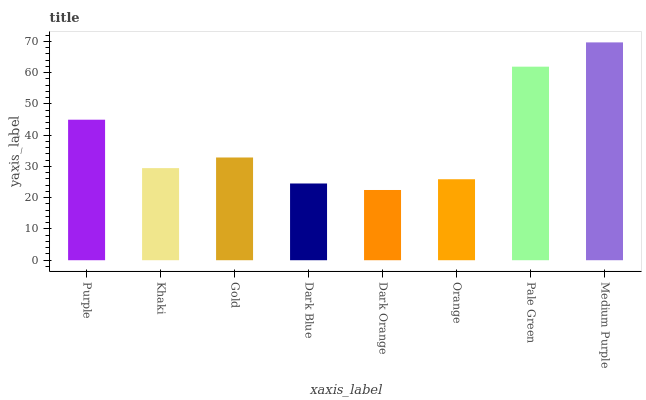Is Dark Orange the minimum?
Answer yes or no. Yes. Is Medium Purple the maximum?
Answer yes or no. Yes. Is Khaki the minimum?
Answer yes or no. No. Is Khaki the maximum?
Answer yes or no. No. Is Purple greater than Khaki?
Answer yes or no. Yes. Is Khaki less than Purple?
Answer yes or no. Yes. Is Khaki greater than Purple?
Answer yes or no. No. Is Purple less than Khaki?
Answer yes or no. No. Is Gold the high median?
Answer yes or no. Yes. Is Khaki the low median?
Answer yes or no. Yes. Is Pale Green the high median?
Answer yes or no. No. Is Dark Orange the low median?
Answer yes or no. No. 